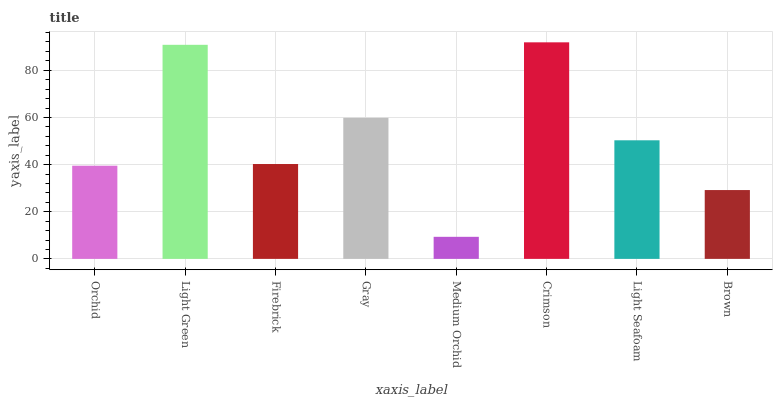Is Medium Orchid the minimum?
Answer yes or no. Yes. Is Crimson the maximum?
Answer yes or no. Yes. Is Light Green the minimum?
Answer yes or no. No. Is Light Green the maximum?
Answer yes or no. No. Is Light Green greater than Orchid?
Answer yes or no. Yes. Is Orchid less than Light Green?
Answer yes or no. Yes. Is Orchid greater than Light Green?
Answer yes or no. No. Is Light Green less than Orchid?
Answer yes or no. No. Is Light Seafoam the high median?
Answer yes or no. Yes. Is Firebrick the low median?
Answer yes or no. Yes. Is Brown the high median?
Answer yes or no. No. Is Light Green the low median?
Answer yes or no. No. 